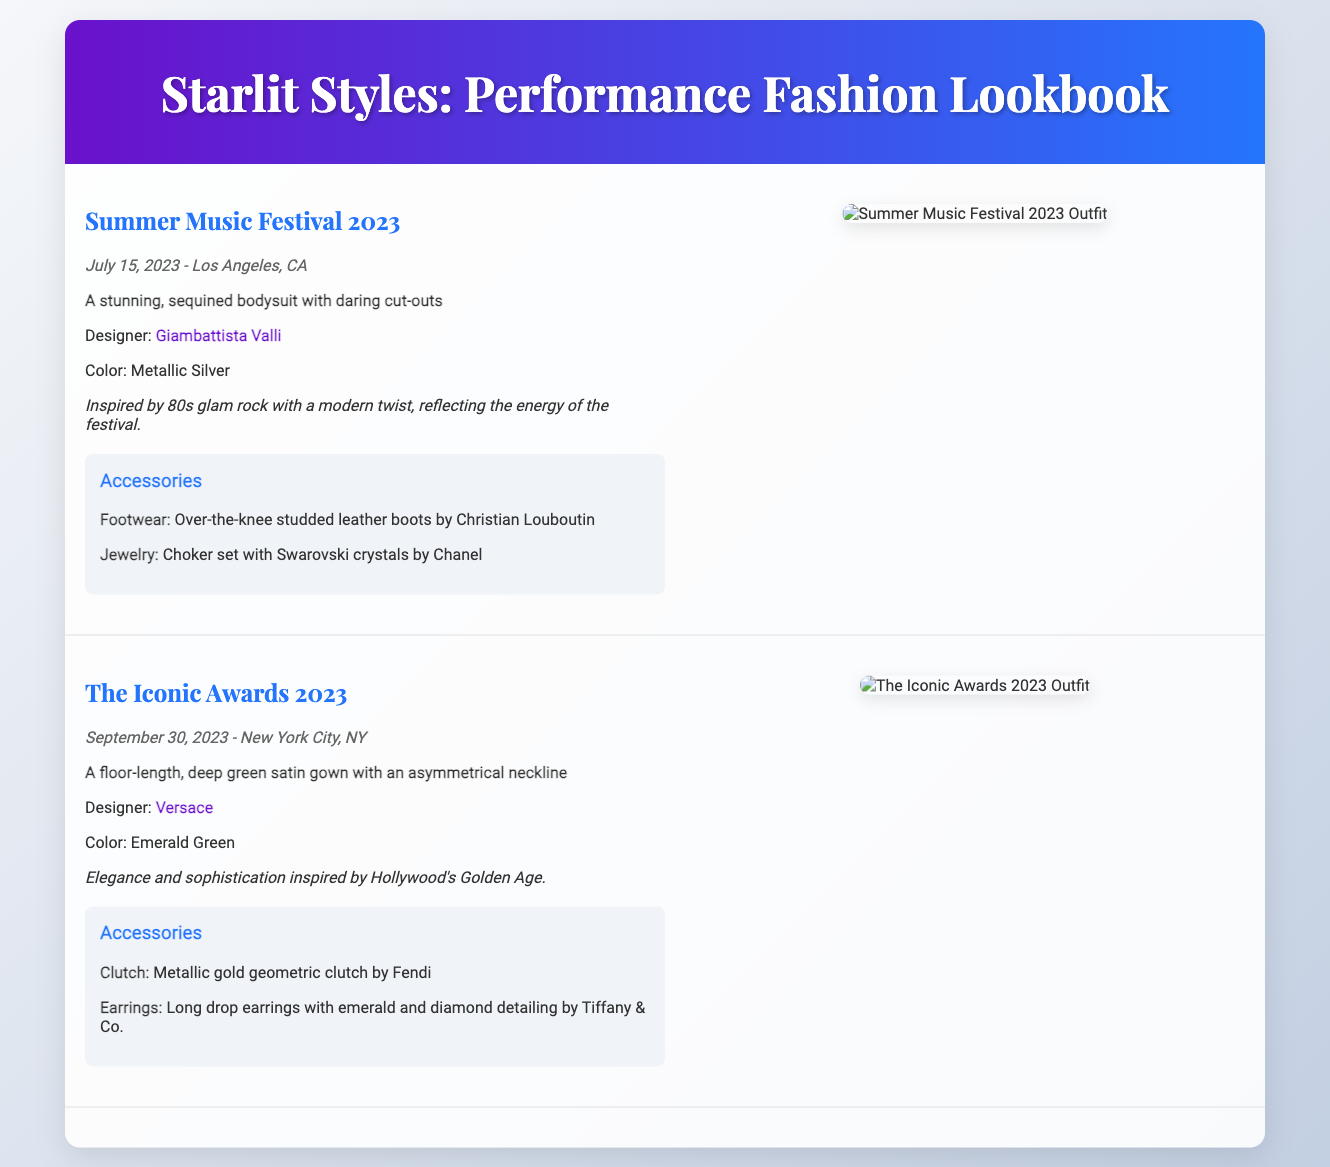what is the name of the first performance? The first performance showcased in the lookbook is titled "Summer Music Festival 2023".
Answer: Summer Music Festival 2023 who designed the outfit for the first performance? The designer credited for the outfit at the first performance is Giambattista Valli.
Answer: Giambattista Valli what color is the gown worn at The Iconic Awards? The gown worn at The Iconic Awards is described as Emerald Green.
Answer: Emerald Green how many performances are included in the lookbook? There are two performances detailed in the lookbook.
Answer: Two what type of accessories were featured with the first performance outfit? The first performance outfit features studded leather boots and a choker set.
Answer: Studded leather boots and a choker set what is the inspiration behind the outfit for The Iconic Awards? The inspiration for the outfit at The Iconic Awards is elegance and sophistication from Hollywood's Golden Age.
Answer: Elegance and sophistication inspired by Hollywood's Golden Age what is the date of the Summer Music Festival? The Summer Music Festival took place on July 15, 2023.
Answer: July 15, 2023 which city hosted The Iconic Awards? The Iconic Awards were held in New York City.
Answer: New York City 